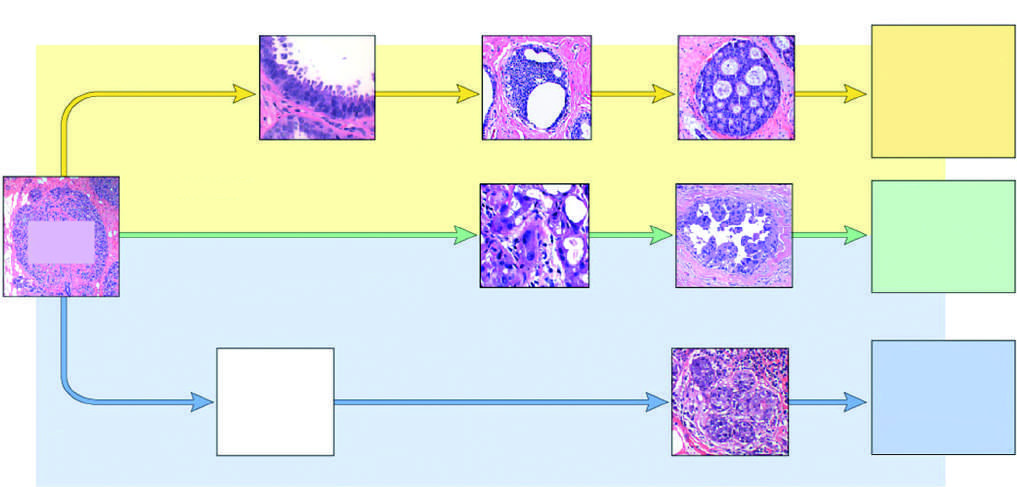what are classified as basal-like by gene expression profiling?
Answer the question using a single word or phrase. The majority of triple-negative cancers 